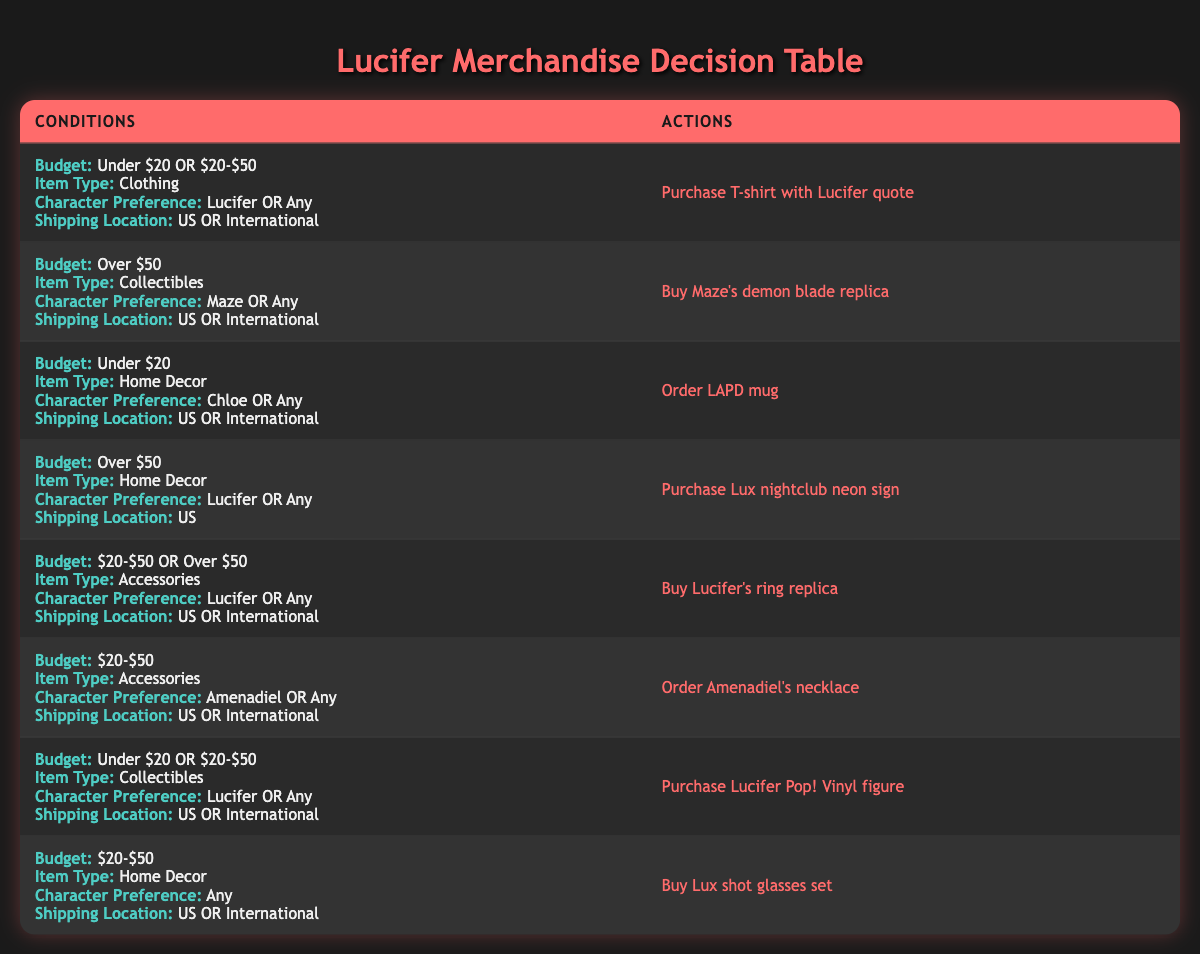What merchandise can I purchase if my budget is under $20? Reviewing the table, I see that under the conditions for "Budget: Under $20," I can purchase the "T-shirt with Lucifer quote" and the "LAPD mug."
Answer: T-shirt with Lucifer quote, LAPD mug Can I order a Lux nightclub neon sign if I live internationally? The conditions for purchasing the "Lux nightclub neon sign" state that the shipping location must be "US," so it cannot be shipped internationally.
Answer: No What are the options for collectible items under $20 or $20-$50? According to the table, I can choose either the "Lucifer Pop! Vinyl figure" (Under $20) or the "Lucifer's ring replica" (between $20-$50).
Answer: Lucifer Pop! Vinyl figure, Lucifer's ring replica If I prefer Maze, which item can I buy that is a collectible? The table specifies that if I prefer Maze and want a collectible item, I can buy "Maze's demon blade replica" (which is over $50).
Answer: Maze's demon blade replica How many items can I purchase if I want to spend between $20 and $50? The table lists five actions under the condition of "Budget: $20-$50": "Buy Lucifer's ring replica," "Order Amenadiel's necklace," "Buy Lux shot glasses set," and purchases that include collectibles and apparel. Counting these, there are four options to choose from.
Answer: Four options Is it possible to buy any accessories for over $50? Reviewing the table shows that there are no accessories listed that cost over $50; the available options for accessories are limited to the price range below that.
Answer: No Which items are available if I prefer any character and my budget is over $50? Looking at the table, two items meet these criteria: "Buy Maze's demon blade replica" (Collectibles) and "Purchase Lux nightclub neon sign" (Home Decor, but only shipped within the US).
Answer: Buy Maze's demon blade replica, Purchase Lux nightclub neon sign Are there any items that can be purchased if my budget is over $50 and I want something related to Lucifer? Yes, the "Purchase Lux nightclub neon sign" and "Buy Lucifer's ring replica" fit these criteria as they are either collectibles or home decor items related to Lucifer.
Answer: Purchase Lux nightclub neon sign, Buy Lucifer's ring replica 